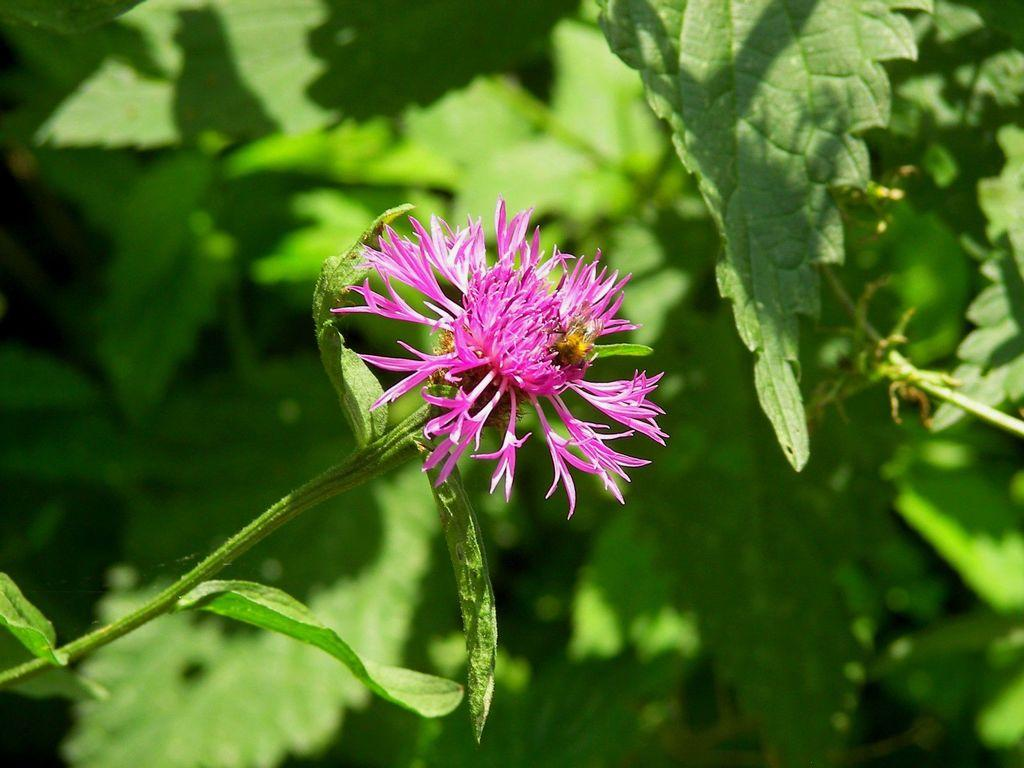What is the main subject of the image? There is a flower in the image. What color is the flower? The flower is pink in color. Are there any other parts of the plant visible in the image? Yes, there are leaves associated with the flower. What type of key is used to unlock the airplane's door in the image? There is no airplane or key present in the image; it features a pink flower with leaves. How does the digestion process of the flower work in the image? Flowers do not have a digestion process, as they are not living organisms capable of consuming food. 